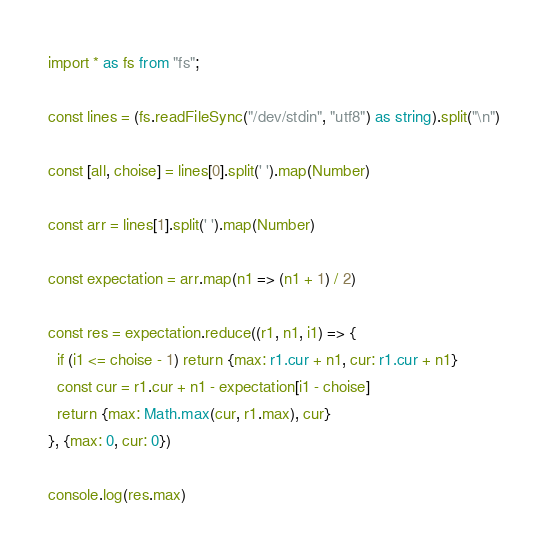Convert code to text. <code><loc_0><loc_0><loc_500><loc_500><_TypeScript_>import * as fs from "fs";

const lines = (fs.readFileSync("/dev/stdin", "utf8") as string).split("\n")

const [all, choise] = lines[0].split(' ').map(Number)

const arr = lines[1].split(' ').map(Number)

const expectation = arr.map(n1 => (n1 + 1) / 2)

const res = expectation.reduce((r1, n1, i1) => {
  if (i1 <= choise - 1) return {max: r1.cur + n1, cur: r1.cur + n1}
  const cur = r1.cur + n1 - expectation[i1 - choise]
  return {max: Math.max(cur, r1.max), cur}
}, {max: 0, cur: 0})

console.log(res.max)</code> 